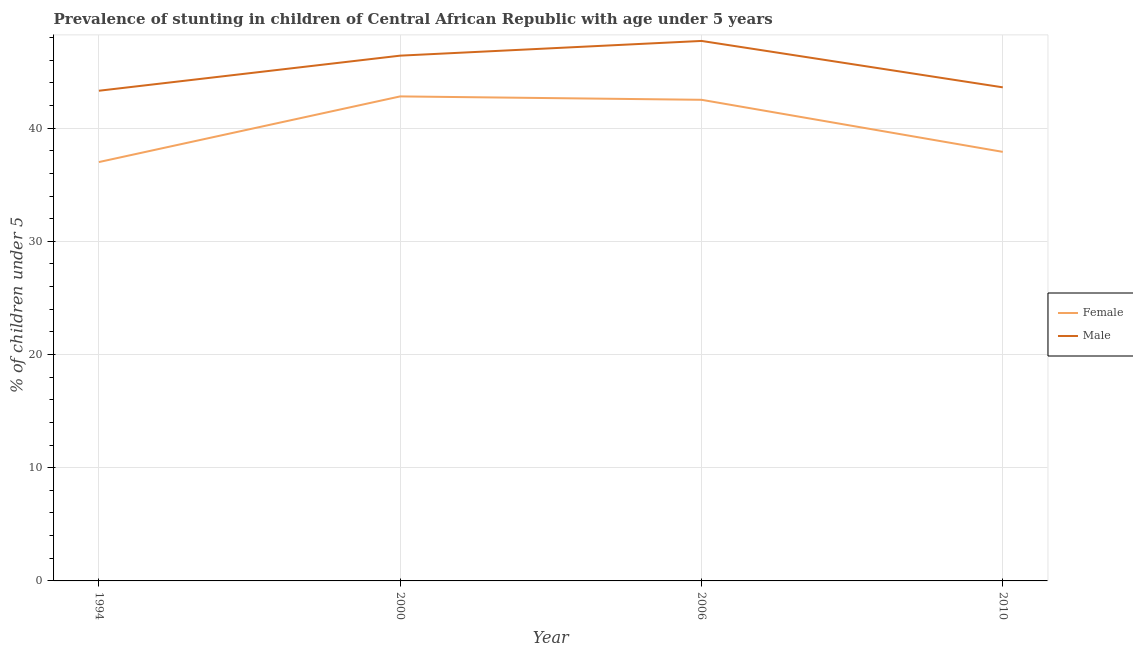How many different coloured lines are there?
Provide a succinct answer. 2. Is the number of lines equal to the number of legend labels?
Offer a very short reply. Yes. What is the percentage of stunted male children in 2000?
Make the answer very short. 46.4. Across all years, what is the maximum percentage of stunted male children?
Keep it short and to the point. 47.7. Across all years, what is the minimum percentage of stunted male children?
Offer a very short reply. 43.3. In which year was the percentage of stunted male children maximum?
Your response must be concise. 2006. What is the total percentage of stunted male children in the graph?
Offer a very short reply. 181. What is the difference between the percentage of stunted male children in 2006 and that in 2010?
Make the answer very short. 4.1. What is the difference between the percentage of stunted female children in 2010 and the percentage of stunted male children in 2000?
Provide a short and direct response. -8.5. What is the average percentage of stunted female children per year?
Ensure brevity in your answer.  40.05. In the year 1994, what is the difference between the percentage of stunted male children and percentage of stunted female children?
Your answer should be compact. 6.3. In how many years, is the percentage of stunted female children greater than 16 %?
Provide a succinct answer. 4. What is the ratio of the percentage of stunted male children in 2006 to that in 2010?
Offer a terse response. 1.09. Is the percentage of stunted male children in 1994 less than that in 2010?
Offer a very short reply. Yes. Is the difference between the percentage of stunted female children in 1994 and 2006 greater than the difference between the percentage of stunted male children in 1994 and 2006?
Offer a very short reply. No. What is the difference between the highest and the second highest percentage of stunted male children?
Provide a short and direct response. 1.3. What is the difference between the highest and the lowest percentage of stunted female children?
Give a very brief answer. 5.8. In how many years, is the percentage of stunted female children greater than the average percentage of stunted female children taken over all years?
Offer a terse response. 2. Does the percentage of stunted male children monotonically increase over the years?
Make the answer very short. No. Is the percentage of stunted female children strictly greater than the percentage of stunted male children over the years?
Ensure brevity in your answer.  No. How many years are there in the graph?
Offer a very short reply. 4. Does the graph contain any zero values?
Offer a very short reply. No. How many legend labels are there?
Provide a succinct answer. 2. What is the title of the graph?
Provide a succinct answer. Prevalence of stunting in children of Central African Republic with age under 5 years. What is the label or title of the Y-axis?
Your response must be concise.  % of children under 5. What is the  % of children under 5 in Male in 1994?
Keep it short and to the point. 43.3. What is the  % of children under 5 of Female in 2000?
Offer a terse response. 42.8. What is the  % of children under 5 in Male in 2000?
Make the answer very short. 46.4. What is the  % of children under 5 of Female in 2006?
Provide a short and direct response. 42.5. What is the  % of children under 5 in Male in 2006?
Make the answer very short. 47.7. What is the  % of children under 5 of Female in 2010?
Keep it short and to the point. 37.9. What is the  % of children under 5 in Male in 2010?
Give a very brief answer. 43.6. Across all years, what is the maximum  % of children under 5 in Female?
Make the answer very short. 42.8. Across all years, what is the maximum  % of children under 5 of Male?
Your answer should be compact. 47.7. Across all years, what is the minimum  % of children under 5 in Male?
Give a very brief answer. 43.3. What is the total  % of children under 5 in Female in the graph?
Offer a very short reply. 160.2. What is the total  % of children under 5 in Male in the graph?
Your answer should be compact. 181. What is the difference between the  % of children under 5 of Female in 1994 and that in 2000?
Provide a succinct answer. -5.8. What is the difference between the  % of children under 5 in Female in 1994 and that in 2006?
Make the answer very short. -5.5. What is the difference between the  % of children under 5 in Female in 1994 and that in 2010?
Provide a short and direct response. -0.9. What is the difference between the  % of children under 5 in Male in 1994 and that in 2010?
Provide a succinct answer. -0.3. What is the difference between the  % of children under 5 in Female in 2000 and that in 2006?
Keep it short and to the point. 0.3. What is the difference between the  % of children under 5 in Female in 2000 and that in 2010?
Offer a very short reply. 4.9. What is the difference between the  % of children under 5 of Female in 1994 and the  % of children under 5 of Male in 2000?
Your answer should be compact. -9.4. What is the difference between the  % of children under 5 of Female in 1994 and the  % of children under 5 of Male in 2006?
Make the answer very short. -10.7. What is the difference between the  % of children under 5 in Female in 1994 and the  % of children under 5 in Male in 2010?
Provide a succinct answer. -6.6. What is the difference between the  % of children under 5 of Female in 2000 and the  % of children under 5 of Male in 2006?
Offer a terse response. -4.9. What is the difference between the  % of children under 5 of Female in 2000 and the  % of children under 5 of Male in 2010?
Offer a very short reply. -0.8. What is the difference between the  % of children under 5 in Female in 2006 and the  % of children under 5 in Male in 2010?
Make the answer very short. -1.1. What is the average  % of children under 5 in Female per year?
Offer a very short reply. 40.05. What is the average  % of children under 5 of Male per year?
Give a very brief answer. 45.25. In the year 1994, what is the difference between the  % of children under 5 in Female and  % of children under 5 in Male?
Provide a succinct answer. -6.3. In the year 2000, what is the difference between the  % of children under 5 of Female and  % of children under 5 of Male?
Offer a very short reply. -3.6. In the year 2010, what is the difference between the  % of children under 5 in Female and  % of children under 5 in Male?
Give a very brief answer. -5.7. What is the ratio of the  % of children under 5 in Female in 1994 to that in 2000?
Offer a very short reply. 0.86. What is the ratio of the  % of children under 5 in Male in 1994 to that in 2000?
Give a very brief answer. 0.93. What is the ratio of the  % of children under 5 of Female in 1994 to that in 2006?
Give a very brief answer. 0.87. What is the ratio of the  % of children under 5 of Male in 1994 to that in 2006?
Give a very brief answer. 0.91. What is the ratio of the  % of children under 5 of Female in 1994 to that in 2010?
Keep it short and to the point. 0.98. What is the ratio of the  % of children under 5 of Male in 1994 to that in 2010?
Ensure brevity in your answer.  0.99. What is the ratio of the  % of children under 5 of Female in 2000 to that in 2006?
Your answer should be compact. 1.01. What is the ratio of the  % of children under 5 in Male in 2000 to that in 2006?
Ensure brevity in your answer.  0.97. What is the ratio of the  % of children under 5 in Female in 2000 to that in 2010?
Provide a short and direct response. 1.13. What is the ratio of the  % of children under 5 of Male in 2000 to that in 2010?
Ensure brevity in your answer.  1.06. What is the ratio of the  % of children under 5 of Female in 2006 to that in 2010?
Offer a very short reply. 1.12. What is the ratio of the  % of children under 5 of Male in 2006 to that in 2010?
Offer a terse response. 1.09. What is the difference between the highest and the second highest  % of children under 5 in Female?
Make the answer very short. 0.3. What is the difference between the highest and the lowest  % of children under 5 in Female?
Your answer should be very brief. 5.8. What is the difference between the highest and the lowest  % of children under 5 in Male?
Your answer should be very brief. 4.4. 